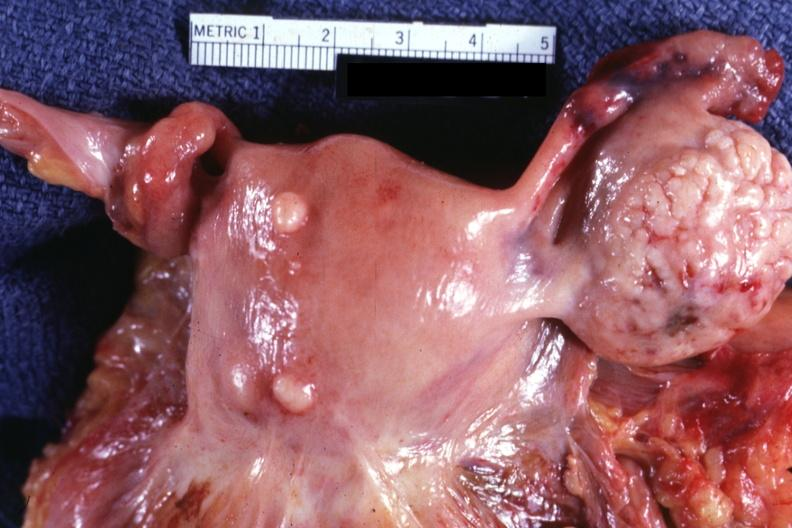s this x-ray of sella turcica after removal postmort present?
Answer the question using a single word or phrase. No 